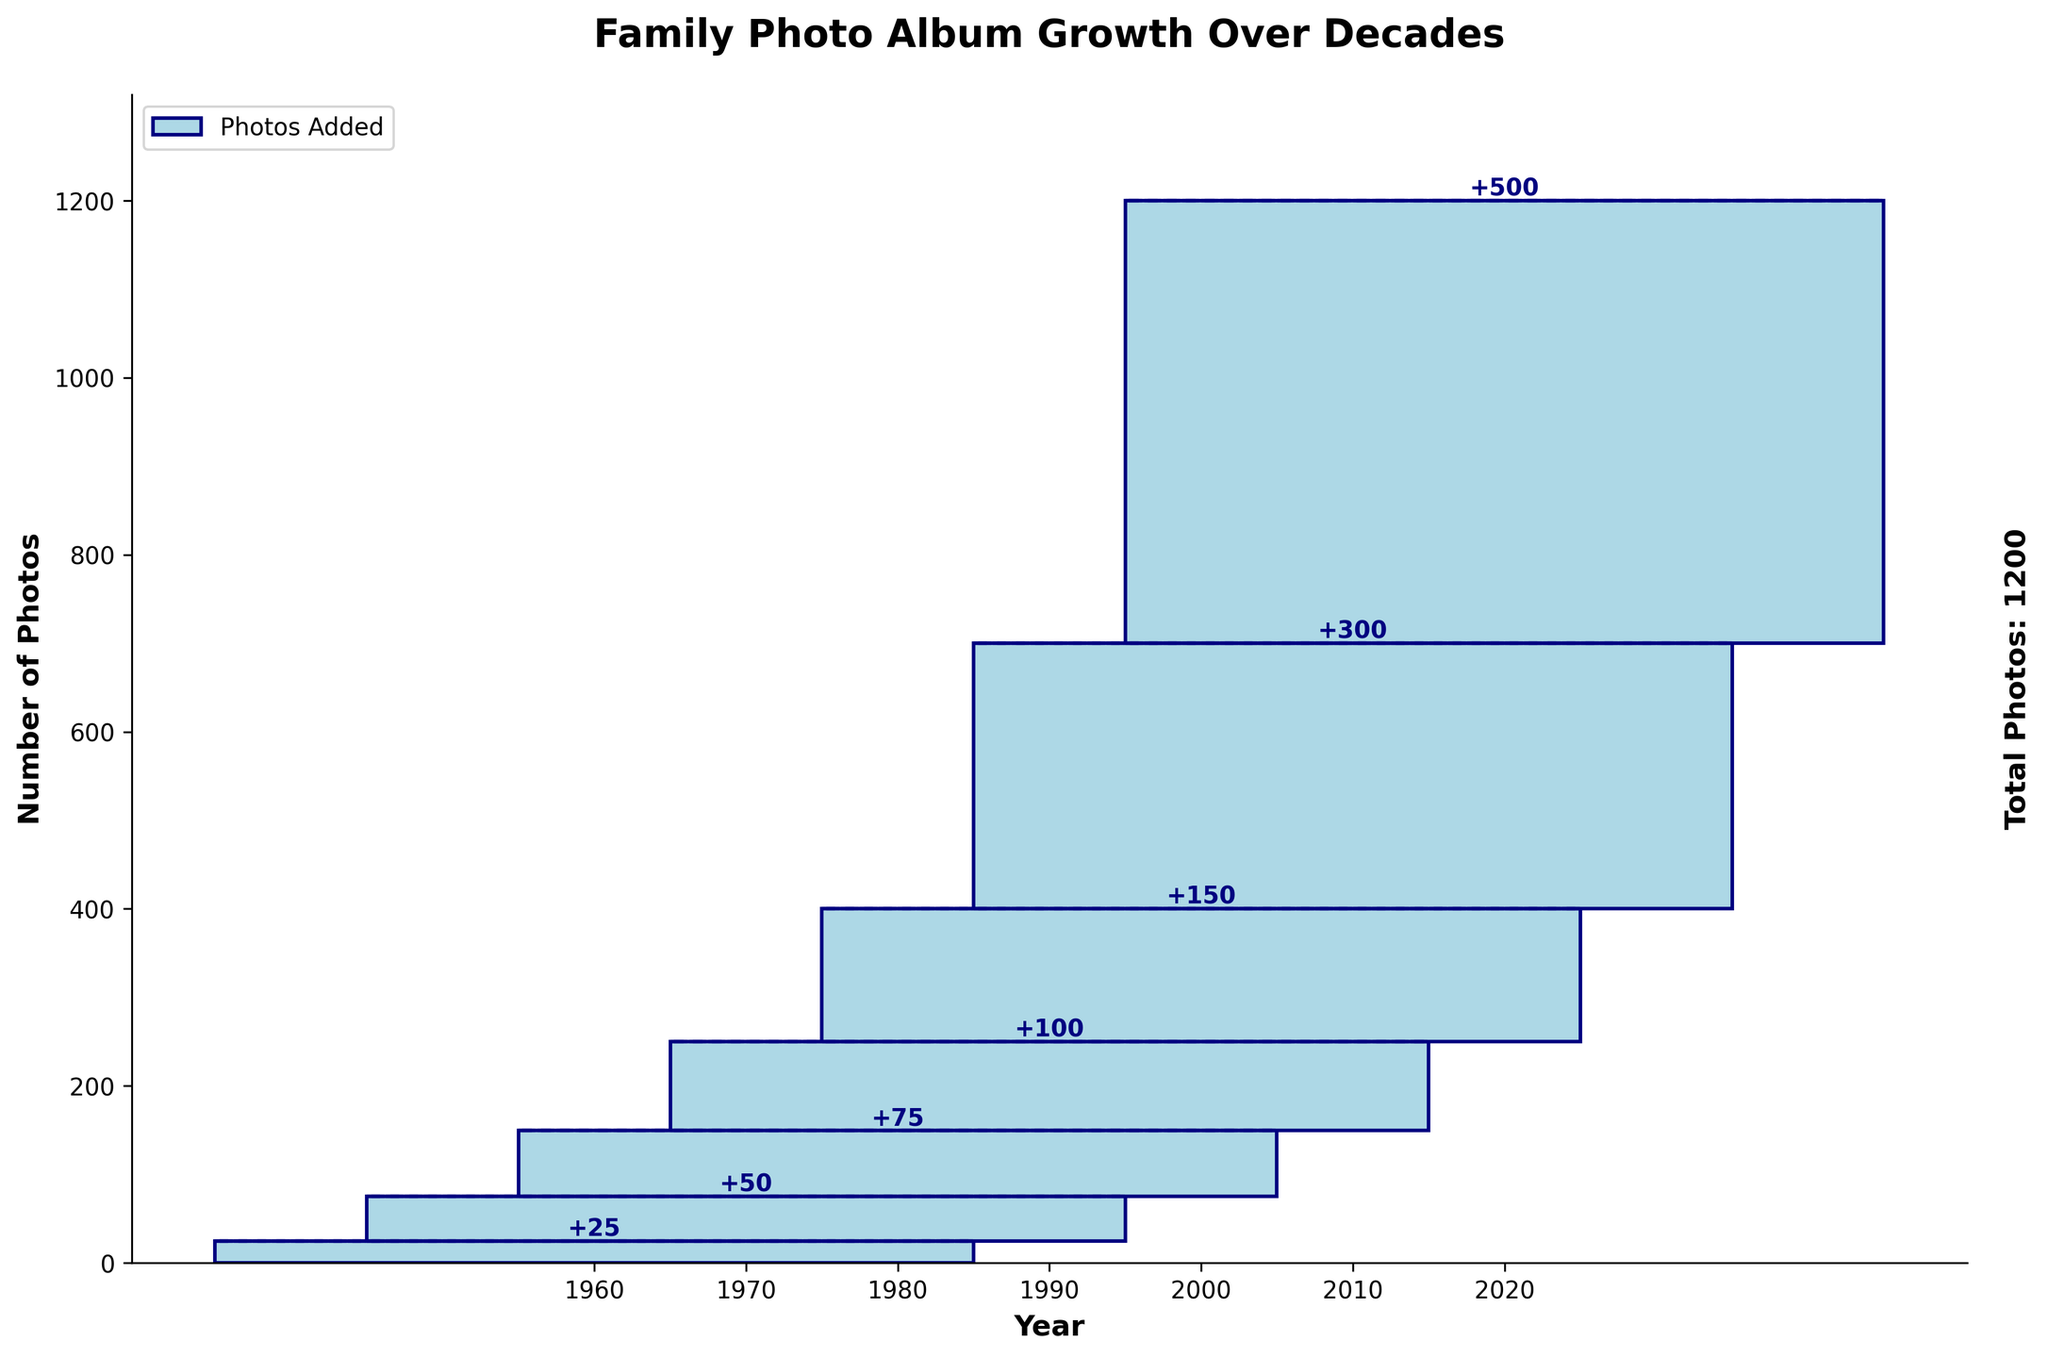what is the title of the chart? The title of the chart is typically displayed at the top of the figure. It is meant to summarize the main subject or focus of the chart. In this case, the title shown is "Family Photo Album Growth Over Decades".
Answer: Family Photo Album Growth Over Decades How many photos were added in the decade 2000s? To determine how many photos were added in a specific decade, we refer to the bar corresponding to that period. The chart indicates that 150 photos were added in the 2000s.
Answer: 150 What is the total number of photos added up to the year 2010? To find the cumulative number of photos up to 2010, sum the photos added in the 1960s, 1970s, 1980s, 1990s, and 2000s, plus those added in 2010: 25 + 50 + 75 + 100 + 150 + 300 = 700.
Answer: 700 Which decade saw the highest number of photos added? The decade with the tallest bar represents the highest number of photos added. In this chart, the 2020s had the highest number of photos added, specifically 500.
Answer: 2020s Did the number of photos added increase or decrease every decade? To answer this, we observe the height of each bar for consecutive decades and compare: 
1960s to 1970s (increase),
1970s to 1980s (increase),
1980s to 1990s (increase),
1990s to 2000s (increase),
2000s to 2010s (increase),
2010s to 2020s (increase).
There is an increase every decade.
Answer: increase How many total photos are accounted for in the chart? The chart includes a total number typically labeled at the end of the cumulative bars. According to the provided chart, the total number of photos is 1200.
Answer: 1200 What is the difference in the number of photos added between the 2010s and 1980s? To find the difference, subtract the number of added photos in the 1980s from those added in the 2010s: 300 - 75 = 225.
Answer: 225 Which decade had the smallest addition of photos, and how many were added then? The smallest bar indicates the lowest number of photos added within a decade. According to the chart, the 1960s had the fewest photos added, with 25.
Answer: 1960s, 25 How does the cumulative number of photos in 1980 compare to that in 1970? To compare, sum the photos added up to 1980 and up to 1970:
Up to 1970: 25 + 50 = 75.
Up to 1980: 25 + 50 + 75 = 150.
So, the cumulative number of photos in 1980 is double that in 1970.
Answer: doubled Which decade had a higher number of photos added, the 2000s or the 1990s? To determine which decade had a higher number of photos added, compare the bar heights or the numerical values:
2000s: 150,
1990s: 100.
The 2000s had more photos added than the 1990s.
Answer: 2000s 